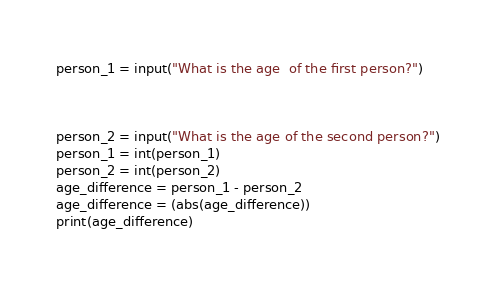<code> <loc_0><loc_0><loc_500><loc_500><_Python_>person_1 = input("What is the age  of the first person?")



person_2 = input("What is the age of the second person?")
person_1 = int(person_1)
person_2 = int(person_2)
age_difference = person_1 - person_2
age_difference = (abs(age_difference))
print(age_difference)


</code> 